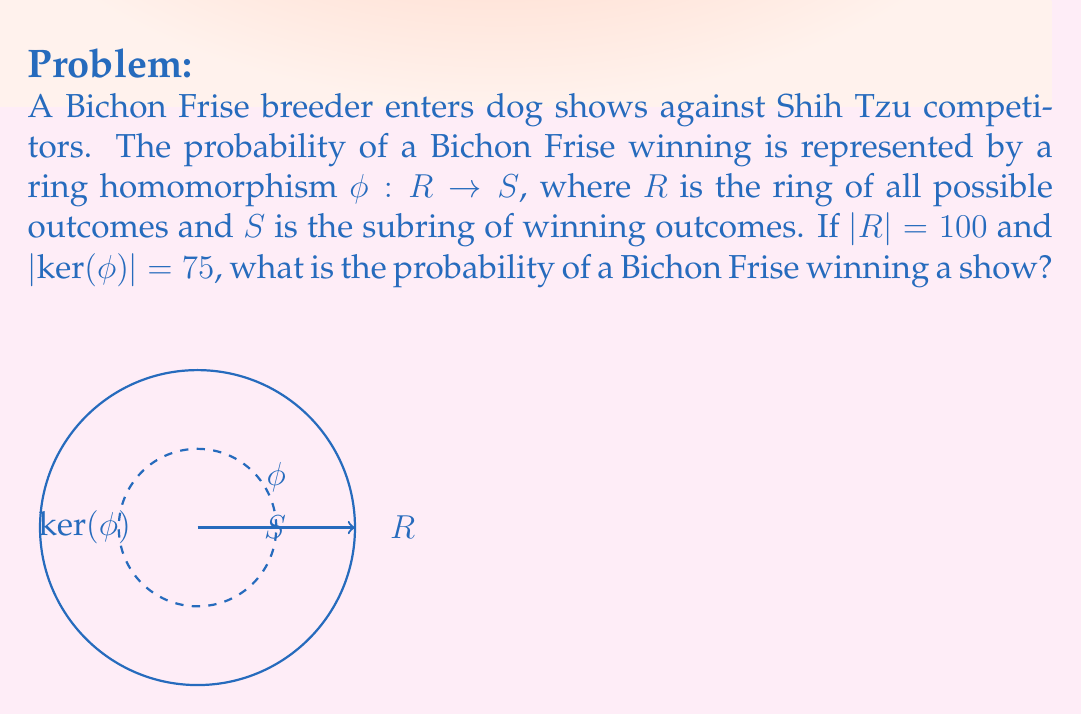What is the answer to this math problem? Let's approach this step-by-step:

1) In ring theory, a ring homomorphism $\phi: R \rightarrow S$ is a function that preserves the algebraic structure between rings $R$ and $S$.

2) The First Isomorphism Theorem for rings states that:

   $$R / \text{ker}(\phi) \cong \text{Im}(\phi)$$

   where $\text{ker}(\phi)$ is the kernel of $\phi$ and $\text{Im}(\phi)$ is the image of $\phi$.

3) In this case, $\text{Im}(\phi)$ represents the winning outcomes, which is isomorphic to $S$.

4) We're given that $|R| = 100$ and $|\text{ker}(\phi)| = 75$.

5) Using the First Isomorphism Theorem:

   $$|R| / |\text{ker}(\phi)| = |\text{Im}(\phi)| = |S|$$

6) Substituting the known values:

   $$100 / 75 = |S|$$

7) Solving for $|S|$:

   $$|S| = 100 / 75 = 4/3 \approx 1.33$$

8) The probability of winning is the ratio of winning outcomes to total outcomes:

   $$P(\text{winning}) = |S| / |R| = (4/3) / 100 = 1/75 \approx 0.0133$$

Therefore, the probability of a Bichon Frise winning a show is 1/75 or approximately 1.33%.
Answer: $1/75$ or $\approx 1.33\%$ 